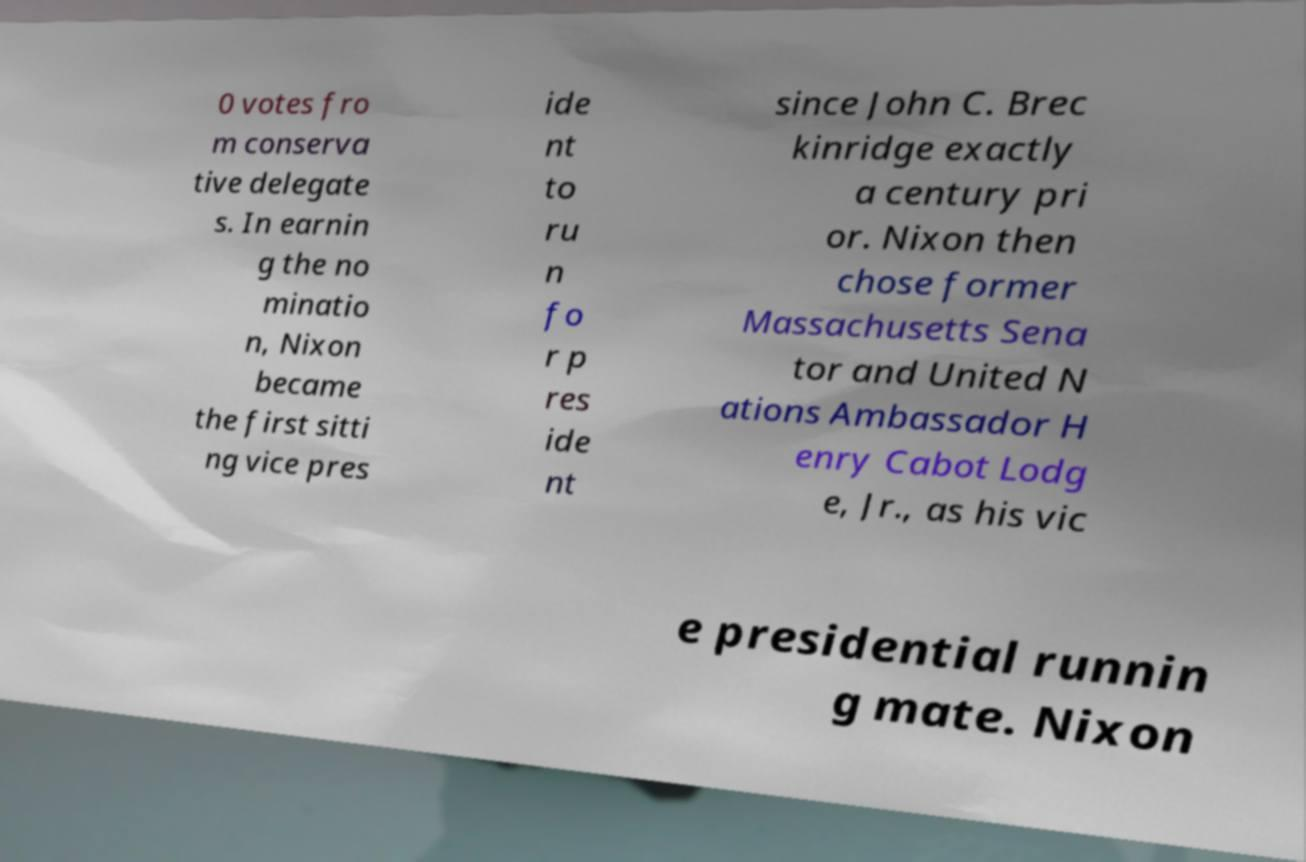I need the written content from this picture converted into text. Can you do that? 0 votes fro m conserva tive delegate s. In earnin g the no minatio n, Nixon became the first sitti ng vice pres ide nt to ru n fo r p res ide nt since John C. Brec kinridge exactly a century pri or. Nixon then chose former Massachusetts Sena tor and United N ations Ambassador H enry Cabot Lodg e, Jr., as his vic e presidential runnin g mate. Nixon 